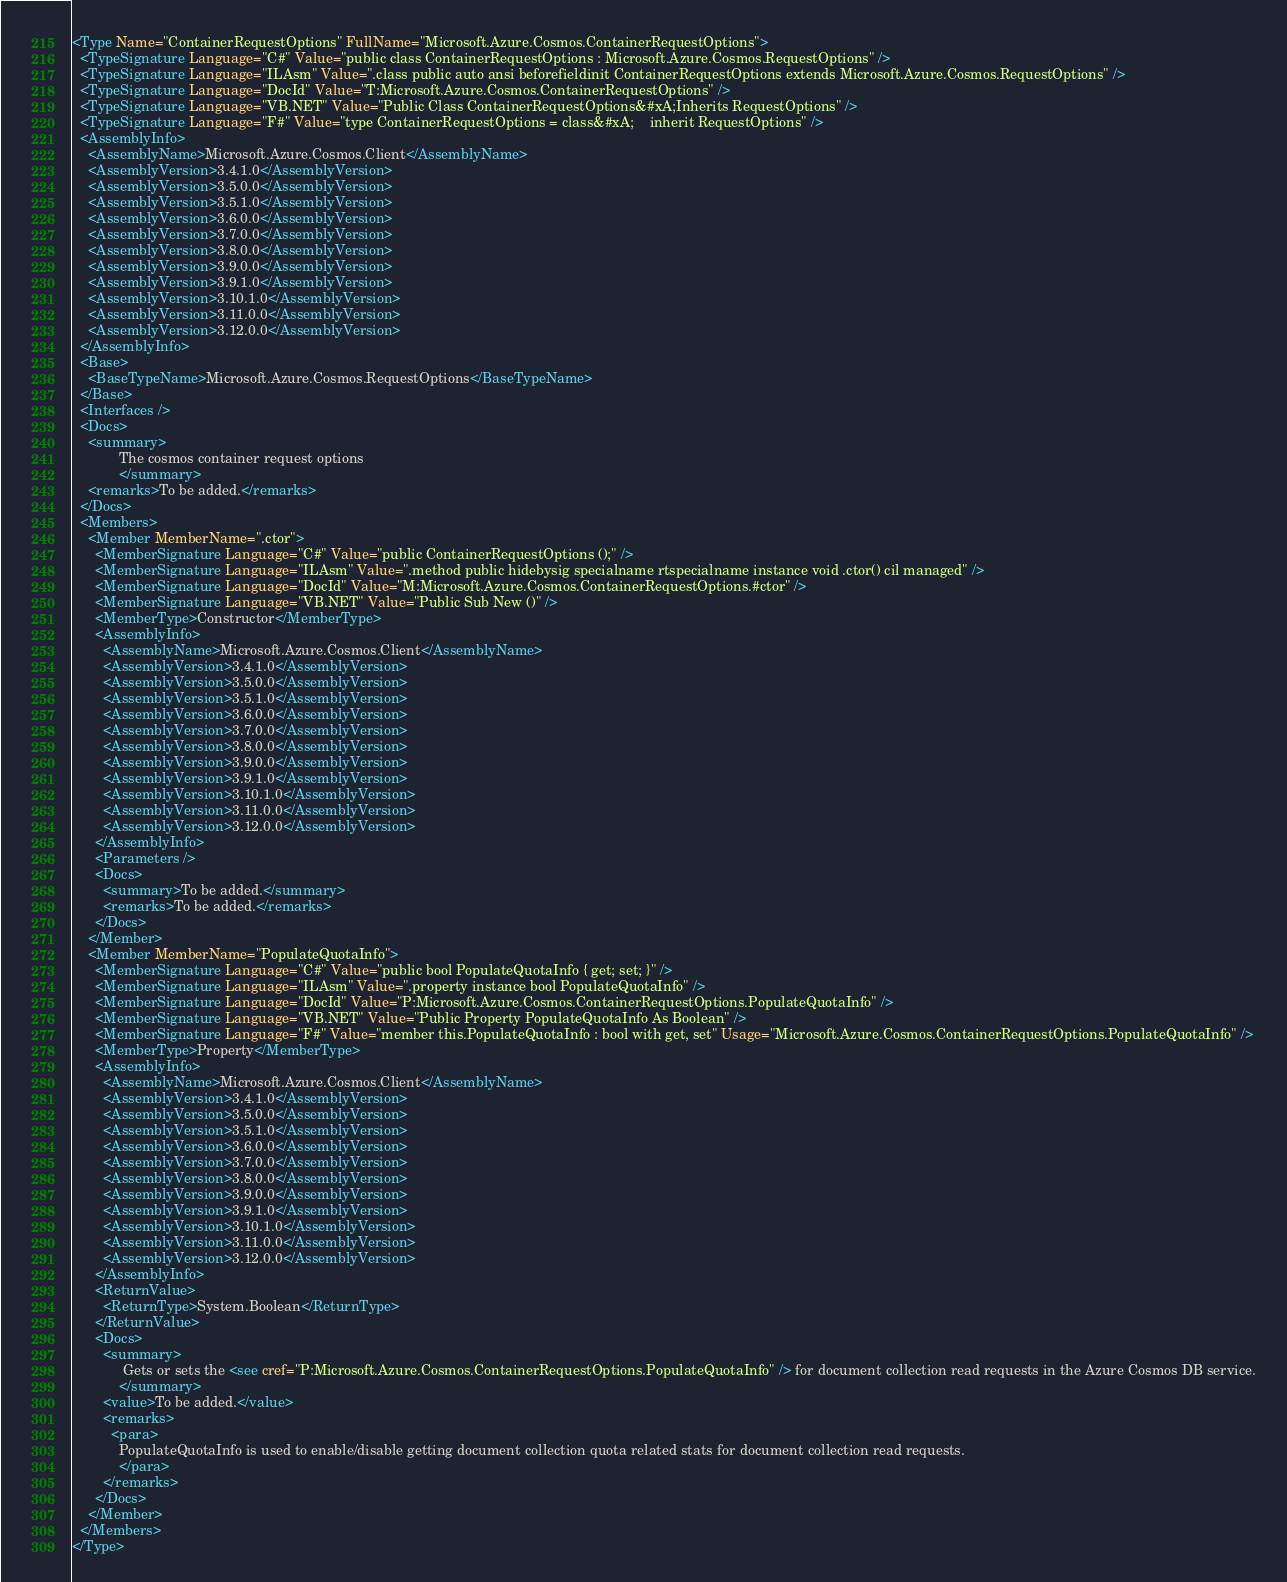<code> <loc_0><loc_0><loc_500><loc_500><_XML_><Type Name="ContainerRequestOptions" FullName="Microsoft.Azure.Cosmos.ContainerRequestOptions">
  <TypeSignature Language="C#" Value="public class ContainerRequestOptions : Microsoft.Azure.Cosmos.RequestOptions" />
  <TypeSignature Language="ILAsm" Value=".class public auto ansi beforefieldinit ContainerRequestOptions extends Microsoft.Azure.Cosmos.RequestOptions" />
  <TypeSignature Language="DocId" Value="T:Microsoft.Azure.Cosmos.ContainerRequestOptions" />
  <TypeSignature Language="VB.NET" Value="Public Class ContainerRequestOptions&#xA;Inherits RequestOptions" />
  <TypeSignature Language="F#" Value="type ContainerRequestOptions = class&#xA;    inherit RequestOptions" />
  <AssemblyInfo>
    <AssemblyName>Microsoft.Azure.Cosmos.Client</AssemblyName>
    <AssemblyVersion>3.4.1.0</AssemblyVersion>
    <AssemblyVersion>3.5.0.0</AssemblyVersion>
    <AssemblyVersion>3.5.1.0</AssemblyVersion>
    <AssemblyVersion>3.6.0.0</AssemblyVersion>
    <AssemblyVersion>3.7.0.0</AssemblyVersion>
    <AssemblyVersion>3.8.0.0</AssemblyVersion>
    <AssemblyVersion>3.9.0.0</AssemblyVersion>
    <AssemblyVersion>3.9.1.0</AssemblyVersion>
    <AssemblyVersion>3.10.1.0</AssemblyVersion>
    <AssemblyVersion>3.11.0.0</AssemblyVersion>
    <AssemblyVersion>3.12.0.0</AssemblyVersion>
  </AssemblyInfo>
  <Base>
    <BaseTypeName>Microsoft.Azure.Cosmos.RequestOptions</BaseTypeName>
  </Base>
  <Interfaces />
  <Docs>
    <summary>
            The cosmos container request options
            </summary>
    <remarks>To be added.</remarks>
  </Docs>
  <Members>
    <Member MemberName=".ctor">
      <MemberSignature Language="C#" Value="public ContainerRequestOptions ();" />
      <MemberSignature Language="ILAsm" Value=".method public hidebysig specialname rtspecialname instance void .ctor() cil managed" />
      <MemberSignature Language="DocId" Value="M:Microsoft.Azure.Cosmos.ContainerRequestOptions.#ctor" />
      <MemberSignature Language="VB.NET" Value="Public Sub New ()" />
      <MemberType>Constructor</MemberType>
      <AssemblyInfo>
        <AssemblyName>Microsoft.Azure.Cosmos.Client</AssemblyName>
        <AssemblyVersion>3.4.1.0</AssemblyVersion>
        <AssemblyVersion>3.5.0.0</AssemblyVersion>
        <AssemblyVersion>3.5.1.0</AssemblyVersion>
        <AssemblyVersion>3.6.0.0</AssemblyVersion>
        <AssemblyVersion>3.7.0.0</AssemblyVersion>
        <AssemblyVersion>3.8.0.0</AssemblyVersion>
        <AssemblyVersion>3.9.0.0</AssemblyVersion>
        <AssemblyVersion>3.9.1.0</AssemblyVersion>
        <AssemblyVersion>3.10.1.0</AssemblyVersion>
        <AssemblyVersion>3.11.0.0</AssemblyVersion>
        <AssemblyVersion>3.12.0.0</AssemblyVersion>
      </AssemblyInfo>
      <Parameters />
      <Docs>
        <summary>To be added.</summary>
        <remarks>To be added.</remarks>
      </Docs>
    </Member>
    <Member MemberName="PopulateQuotaInfo">
      <MemberSignature Language="C#" Value="public bool PopulateQuotaInfo { get; set; }" />
      <MemberSignature Language="ILAsm" Value=".property instance bool PopulateQuotaInfo" />
      <MemberSignature Language="DocId" Value="P:Microsoft.Azure.Cosmos.ContainerRequestOptions.PopulateQuotaInfo" />
      <MemberSignature Language="VB.NET" Value="Public Property PopulateQuotaInfo As Boolean" />
      <MemberSignature Language="F#" Value="member this.PopulateQuotaInfo : bool with get, set" Usage="Microsoft.Azure.Cosmos.ContainerRequestOptions.PopulateQuotaInfo" />
      <MemberType>Property</MemberType>
      <AssemblyInfo>
        <AssemblyName>Microsoft.Azure.Cosmos.Client</AssemblyName>
        <AssemblyVersion>3.4.1.0</AssemblyVersion>
        <AssemblyVersion>3.5.0.0</AssemblyVersion>
        <AssemblyVersion>3.5.1.0</AssemblyVersion>
        <AssemblyVersion>3.6.0.0</AssemblyVersion>
        <AssemblyVersion>3.7.0.0</AssemblyVersion>
        <AssemblyVersion>3.8.0.0</AssemblyVersion>
        <AssemblyVersion>3.9.0.0</AssemblyVersion>
        <AssemblyVersion>3.9.1.0</AssemblyVersion>
        <AssemblyVersion>3.10.1.0</AssemblyVersion>
        <AssemblyVersion>3.11.0.0</AssemblyVersion>
        <AssemblyVersion>3.12.0.0</AssemblyVersion>
      </AssemblyInfo>
      <ReturnValue>
        <ReturnType>System.Boolean</ReturnType>
      </ReturnValue>
      <Docs>
        <summary>
             Gets or sets the <see cref="P:Microsoft.Azure.Cosmos.ContainerRequestOptions.PopulateQuotaInfo" /> for document collection read requests in the Azure Cosmos DB service.
            </summary>
        <value>To be added.</value>
        <remarks>
          <para>
            PopulateQuotaInfo is used to enable/disable getting document collection quota related stats for document collection read requests.
            </para>
        </remarks>
      </Docs>
    </Member>
  </Members>
</Type>
</code> 